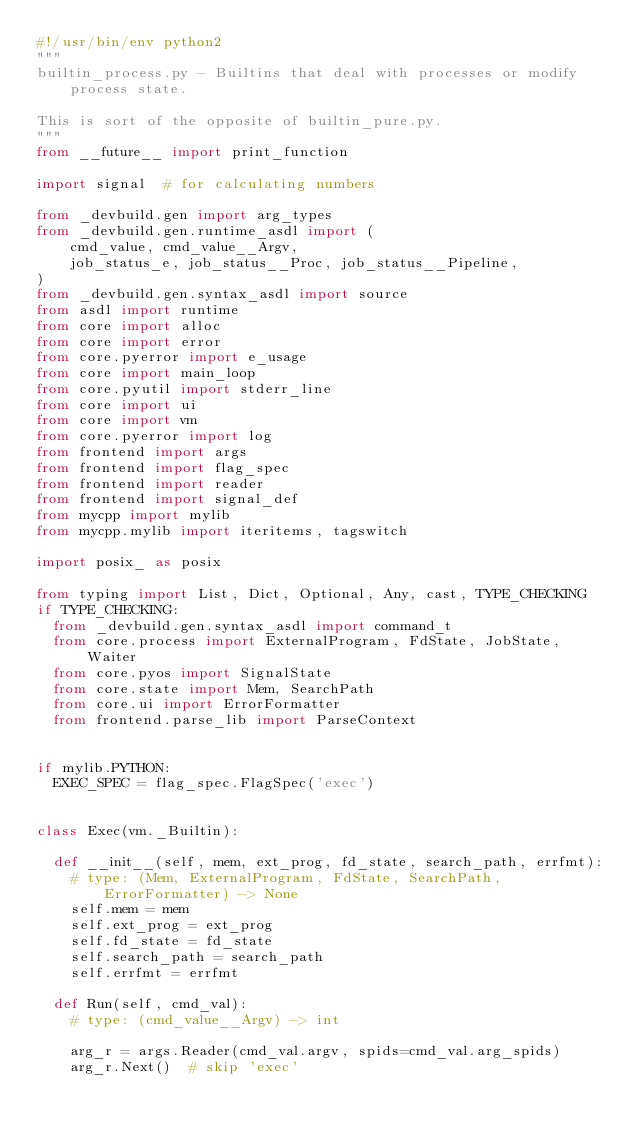Convert code to text. <code><loc_0><loc_0><loc_500><loc_500><_Python_>#!/usr/bin/env python2
"""
builtin_process.py - Builtins that deal with processes or modify process state.

This is sort of the opposite of builtin_pure.py.
"""
from __future__ import print_function

import signal  # for calculating numbers

from _devbuild.gen import arg_types
from _devbuild.gen.runtime_asdl import (
    cmd_value, cmd_value__Argv,
    job_status_e, job_status__Proc, job_status__Pipeline,
)
from _devbuild.gen.syntax_asdl import source
from asdl import runtime
from core import alloc
from core import error
from core.pyerror import e_usage
from core import main_loop
from core.pyutil import stderr_line
from core import ui
from core import vm
from core.pyerror import log
from frontend import args
from frontend import flag_spec
from frontend import reader
from frontend import signal_def
from mycpp import mylib
from mycpp.mylib import iteritems, tagswitch

import posix_ as posix

from typing import List, Dict, Optional, Any, cast, TYPE_CHECKING
if TYPE_CHECKING:
  from _devbuild.gen.syntax_asdl import command_t
  from core.process import ExternalProgram, FdState, JobState, Waiter
  from core.pyos import SignalState
  from core.state import Mem, SearchPath
  from core.ui import ErrorFormatter
  from frontend.parse_lib import ParseContext


if mylib.PYTHON:
  EXEC_SPEC = flag_spec.FlagSpec('exec')


class Exec(vm._Builtin):

  def __init__(self, mem, ext_prog, fd_state, search_path, errfmt):
    # type: (Mem, ExternalProgram, FdState, SearchPath, ErrorFormatter) -> None
    self.mem = mem
    self.ext_prog = ext_prog
    self.fd_state = fd_state
    self.search_path = search_path
    self.errfmt = errfmt

  def Run(self, cmd_val):
    # type: (cmd_value__Argv) -> int

    arg_r = args.Reader(cmd_val.argv, spids=cmd_val.arg_spids)
    arg_r.Next()  # skip 'exec'</code> 